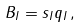Convert formula to latex. <formula><loc_0><loc_0><loc_500><loc_500>B _ { I } = s _ { I } q _ { I } \, ,</formula> 